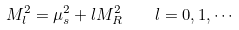<formula> <loc_0><loc_0><loc_500><loc_500>M _ { l } ^ { 2 } = \mu _ { s } ^ { 2 } + l M _ { R } ^ { 2 } \quad l = 0 , 1 , \cdots</formula> 